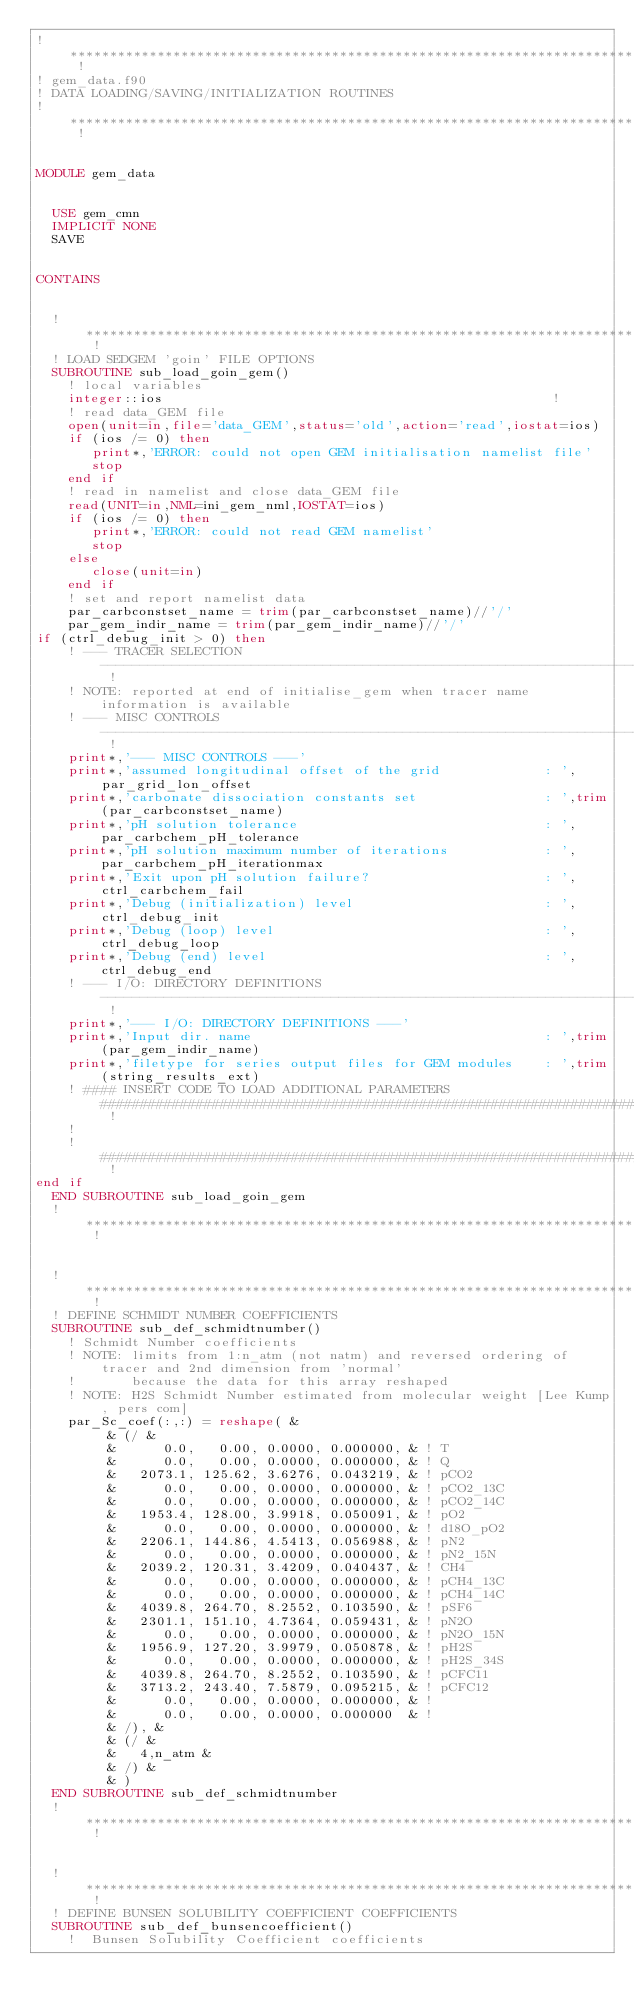<code> <loc_0><loc_0><loc_500><loc_500><_FORTRAN_>! ******************************************************************************************************************************** !
! gem_data.f90
! DATA LOADING/SAVING/INITIALIZATION ROUTINES
! ******************************************************************************************************************************** !


MODULE gem_data

  
  USE gem_cmn
  IMPLICIT NONE
  SAVE
  
  
CONTAINS
  
  
  ! ****************************************************************************************************************************** !
  ! LOAD SEDGEM 'goin' FILE OPTIONS
  SUBROUTINE sub_load_goin_gem()
    ! local variables
    integer::ios                                                 !
    ! read data_GEM file
    open(unit=in,file='data_GEM',status='old',action='read',iostat=ios)
    if (ios /= 0) then
       print*,'ERROR: could not open GEM initialisation namelist file'
       stop
    end if
    ! read in namelist and close data_GEM file
    read(UNIT=in,NML=ini_gem_nml,IOSTAT=ios)
    if (ios /= 0) then
       print*,'ERROR: could not read GEM namelist'
       stop
    else
       close(unit=in)
    end if
    ! set and report namelist data
    par_carbconstset_name = trim(par_carbconstset_name)//'/'
    par_gem_indir_name = trim(par_gem_indir_name)//'/'
if (ctrl_debug_init > 0) then
    ! --- TRACER SELECTION  ------------------------------------------------------------------------------------------------------ !
    ! NOTE: reported at end of initialise_gem when tracer name information is available
    ! --- MISC CONTROLS  --------------------------------------------------------------------------------------------------------- !
    print*,'--- MISC CONTROLS ---'
    print*,'assumed longitudinal offset of the grid             : ',par_grid_lon_offset
    print*,'carbonate dissociation constants set                : ',trim(par_carbconstset_name)
    print*,'pH solution tolerance                               : ',par_carbchem_pH_tolerance
    print*,'pH solution maximum number of iterations            : ',par_carbchem_pH_iterationmax
    print*,'Exit upon pH solution failure?                      : ',ctrl_carbchem_fail
    print*,'Debug (initialization) level                        : ',ctrl_debug_init
    print*,'Debug (loop) level                                  : ',ctrl_debug_loop
    print*,'Debug (end) level                                   : ',ctrl_debug_end
    ! --- I/O: DIRECTORY DEFINITIONS --------------------------------------------------------------------------------------------- !
    print*,'--- I/O: DIRECTORY DEFINITIONS ---'
    print*,'Input dir. name                                     : ',trim(par_gem_indir_name)
    print*,'filetype for series output files for GEM modules    : ',trim(string_results_ext)
    ! #### INSERT CODE TO LOAD ADDITIONAL PARAMETERS ############################################################################# !
    !
    ! ############################################################################################################################ !
end if
  END SUBROUTINE sub_load_goin_gem
  ! ****************************************************************************************************************************** !


  ! ****************************************************************************************************************************** !
  ! DEFINE SCHMIDT NUMBER COEFFICIENTS
  SUBROUTINE sub_def_schmidtnumber()
    ! Schmidt Number coefficients
    ! NOTE: limits from 1:n_atm (not natm) and reversed ordering of tracer and 2nd dimension from 'normal'
    !       because the data for this array reshaped
    ! NOTE: H2S Schmidt Number estimated from molecular weight [Lee Kump, pers com]
    par_Sc_coef(:,:) = reshape( &
         & (/ &
         &      0.0,   0.00, 0.0000, 0.000000, & ! T
         &      0.0,   0.00, 0.0000, 0.000000, & ! Q
         &   2073.1, 125.62, 3.6276, 0.043219, & ! pCO2
         &      0.0,   0.00, 0.0000, 0.000000, & ! pCO2_13C
         &      0.0,   0.00, 0.0000, 0.000000, & ! pCO2_14C
         &   1953.4, 128.00, 3.9918, 0.050091, & ! pO2
         &      0.0,   0.00, 0.0000, 0.000000, & ! d18O_pO2
         &   2206.1, 144.86, 4.5413, 0.056988, & ! pN2
         &      0.0,   0.00, 0.0000, 0.000000, & ! pN2_15N
         &   2039.2, 120.31, 3.4209, 0.040437, & ! CH4
         &      0.0,   0.00, 0.0000, 0.000000, & ! pCH4_13C
         &      0.0,   0.00, 0.0000, 0.000000, & ! pCH4_14C
         &   4039.8, 264.70, 8.2552, 0.103590, & ! pSF6
         &   2301.1, 151.10, 4.7364, 0.059431, & ! pN2O
         &      0.0,   0.00, 0.0000, 0.000000, & ! pN2O_15N
         &   1956.9, 127.20, 3.9979, 0.050878, & ! pH2S
         &      0.0,   0.00, 0.0000, 0.000000, & ! pH2S_34S
         &   4039.8, 264.70, 8.2552, 0.103590, & ! pCFC11
         &   3713.2, 243.40, 7.5879, 0.095215, & ! pCFC12
         &      0.0,   0.00, 0.0000, 0.000000, & ! 
         &      0.0,   0.00, 0.0000, 0.000000  & ! 
         & /), &
         & (/ &
         &   4,n_atm &
         & /) &
         & )
  END SUBROUTINE sub_def_schmidtnumber
  ! ****************************************************************************************************************************** !


  ! ****************************************************************************************************************************** !
  ! DEFINE BUNSEN SOLUBILITY COEFFICIENT COEFFICIENTS
  SUBROUTINE sub_def_bunsencoefficient()
    !  Bunsen Solubility Coefficient coefficients</code> 